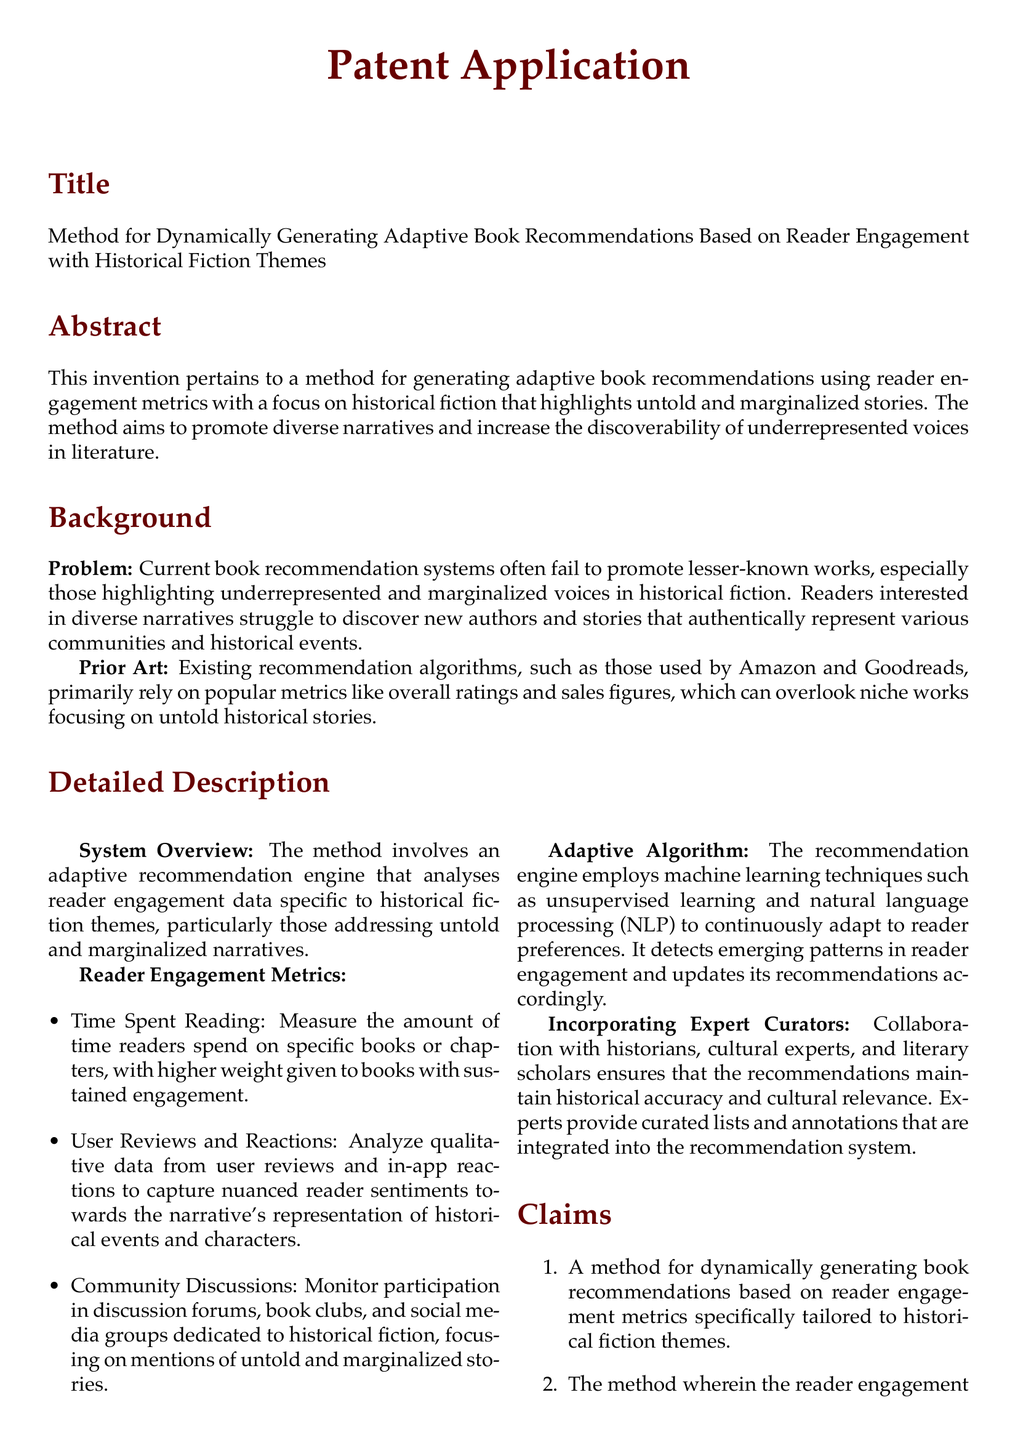What is the title of the patent application? The title is listed in the document's section for the title.
Answer: Method for Dynamically Generating Adaptive Book Recommendations Based on Reader Engagement with Historical Fiction Themes What is the primary focus of the method described in the patent application? The focus is outlined in the abstract section, which describes the method's aim.
Answer: Reader engagement with historical fiction themes highlighting untold and marginalized stories What are the two main components of reader engagement metrics? The document details specific reader engagement metrics in the detailed description section.
Answer: Time Spent Reading and User Reviews and Reactions What machine learning techniques are employed in the adaptive algorithm? The use of machine learning techniques is mentioned in the detailed description under the adaptive algorithm section.
Answer: Unsupervised learning and natural language processing (NLP) How does the recommendation system ensure historical accuracy? The section on incorporating expert curators explains how accuracy is maintained.
Answer: Collaboration with historians, cultural experts, and literary scholars What is one advantage of this method according to the document? The advantages of the method are listed towards the end of the document.
Answer: Promotes Diversity How many claims does the patent application make? The number of claims is specified in the claims section of the document.
Answer: Four What aspect of reader engagement does the method specifically analyze? The detailed description provides insight into the specific engagement analyzed by the method.
Answer: Historical fiction themes addressing untold and marginalized narratives What does the conclusion of the patent application address? The conclusion summarizes the main outcomes or aims of the application.
Answer: Limitations of conventional recommendation systems 